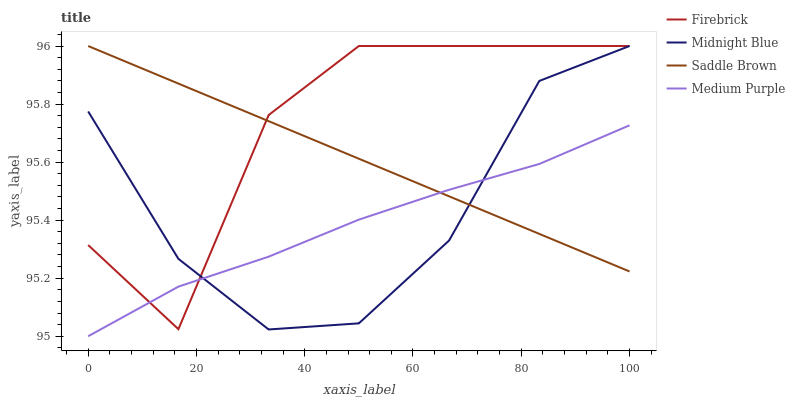Does Medium Purple have the minimum area under the curve?
Answer yes or no. Yes. Does Firebrick have the maximum area under the curve?
Answer yes or no. Yes. Does Midnight Blue have the minimum area under the curve?
Answer yes or no. No. Does Midnight Blue have the maximum area under the curve?
Answer yes or no. No. Is Saddle Brown the smoothest?
Answer yes or no. Yes. Is Firebrick the roughest?
Answer yes or no. Yes. Is Midnight Blue the smoothest?
Answer yes or no. No. Is Midnight Blue the roughest?
Answer yes or no. No. Does Medium Purple have the lowest value?
Answer yes or no. Yes. Does Firebrick have the lowest value?
Answer yes or no. No. Does Saddle Brown have the highest value?
Answer yes or no. Yes. Does Midnight Blue intersect Medium Purple?
Answer yes or no. Yes. Is Midnight Blue less than Medium Purple?
Answer yes or no. No. Is Midnight Blue greater than Medium Purple?
Answer yes or no. No. 